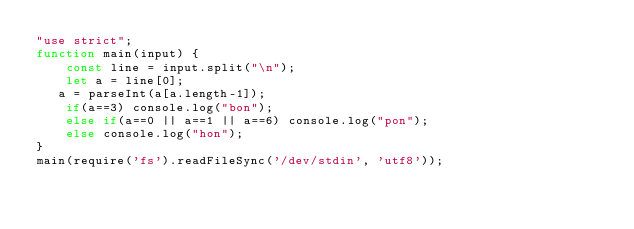Convert code to text. <code><loc_0><loc_0><loc_500><loc_500><_JavaScript_>"use strict";
function main(input) {
    const line = input.split("\n");
    let a = line[0];
   a = parseInt(a[a.length-1]);
    if(a==3) console.log("bon");
    else if(a==0 || a==1 || a==6) console.log("pon");
    else console.log("hon");
}
main(require('fs').readFileSync('/dev/stdin', 'utf8'));
</code> 